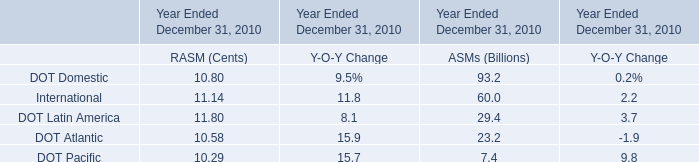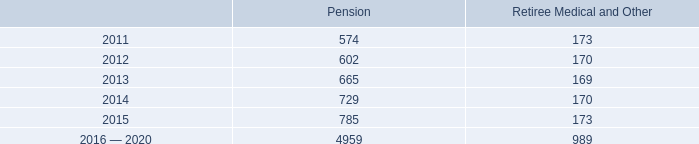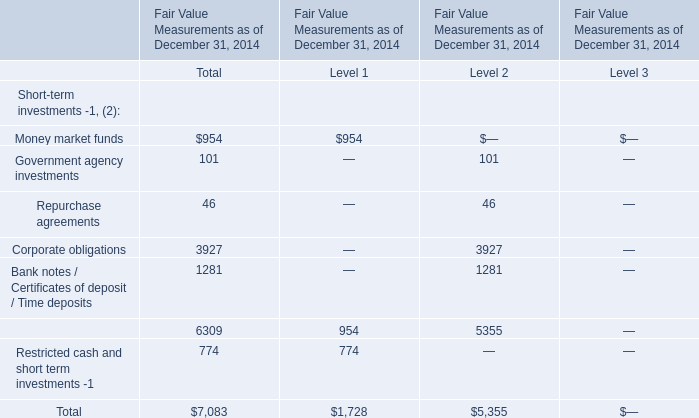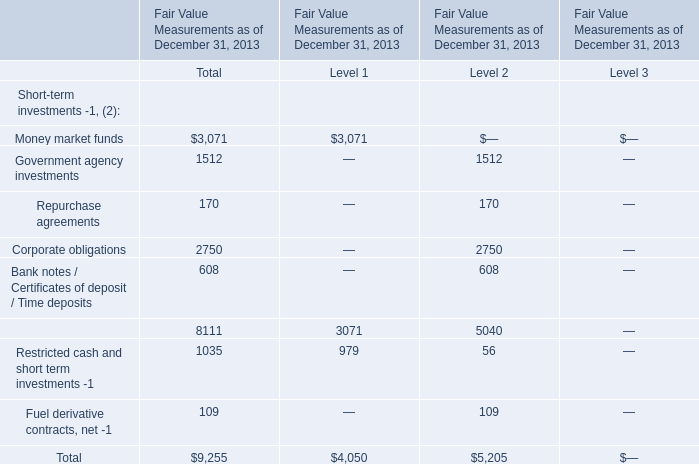what is the percentage decrease in the minimum contribution to benefit pension plans due to the relied act? 
Computations: ((460 - 525) / 525)
Answer: -0.12381. 